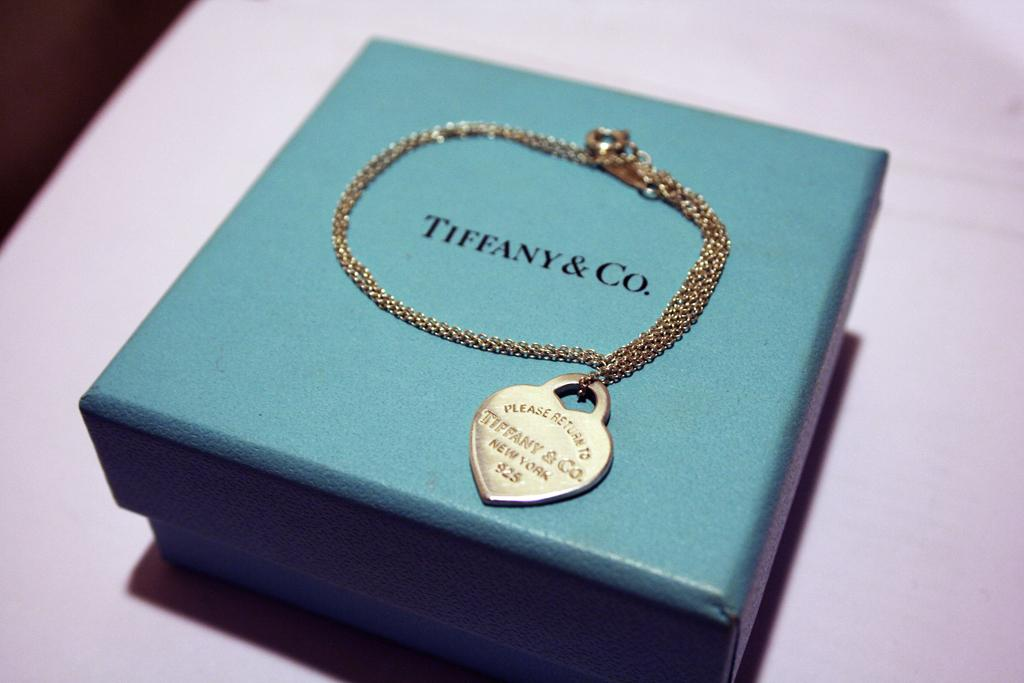What object is present in the image that could contain items? There is a box in the image that could contain items. Is there any writing or text on the box? Yes, there is text written on the box. What is placed on top of the box? There is a locket and a chain on top of the box. How does the calculator help during the earthquake in the image? There is no calculator or earthquake present in the image. What type of legal advice is the lawyer providing in the image? There is no lawyer present in the image. 